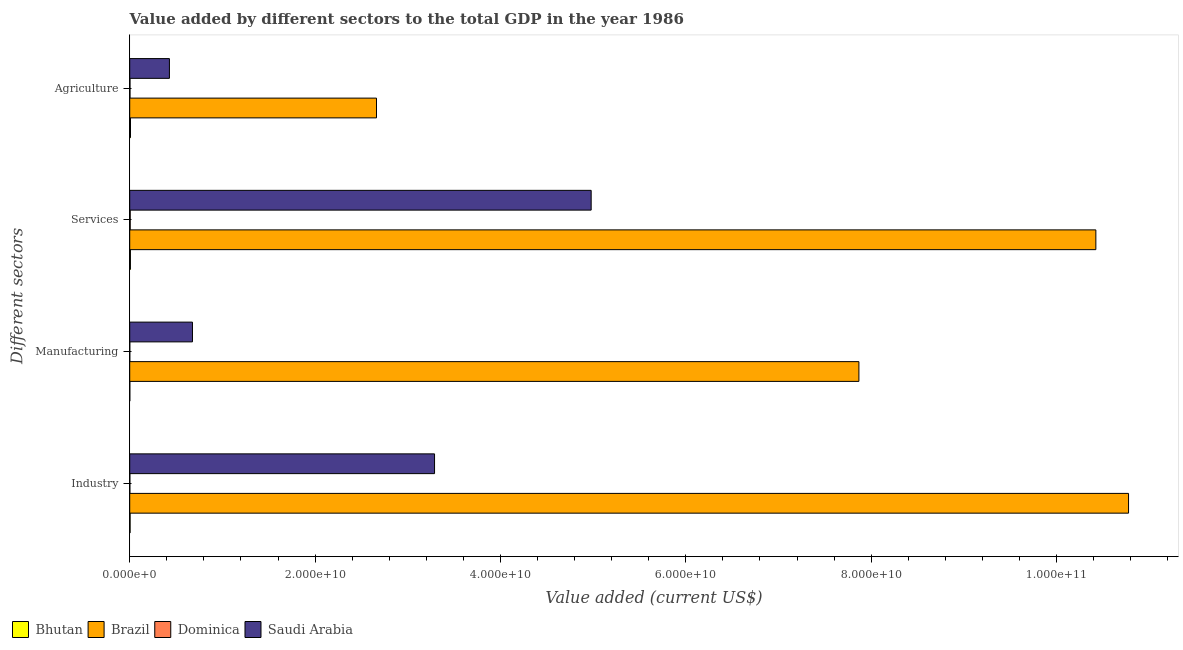How many groups of bars are there?
Give a very brief answer. 4. Are the number of bars per tick equal to the number of legend labels?
Make the answer very short. Yes. How many bars are there on the 3rd tick from the bottom?
Ensure brevity in your answer.  4. What is the label of the 4th group of bars from the top?
Provide a succinct answer. Industry. What is the value added by manufacturing sector in Brazil?
Offer a very short reply. 7.87e+1. Across all countries, what is the maximum value added by services sector?
Make the answer very short. 1.04e+11. Across all countries, what is the minimum value added by industrial sector?
Offer a very short reply. 1.36e+07. In which country was the value added by agricultural sector maximum?
Offer a terse response. Brazil. In which country was the value added by services sector minimum?
Ensure brevity in your answer.  Dominica. What is the total value added by manufacturing sector in the graph?
Provide a short and direct response. 8.55e+1. What is the difference between the value added by manufacturing sector in Dominica and that in Saudi Arabia?
Your answer should be very brief. -6.76e+09. What is the difference between the value added by agricultural sector in Bhutan and the value added by manufacturing sector in Dominica?
Offer a terse response. 7.71e+07. What is the average value added by agricultural sector per country?
Offer a very short reply. 7.76e+09. What is the difference between the value added by services sector and value added by manufacturing sector in Dominica?
Your response must be concise. 4.55e+07. What is the ratio of the value added by manufacturing sector in Bhutan to that in Dominica?
Provide a succinct answer. 1.63. What is the difference between the highest and the second highest value added by industrial sector?
Give a very brief answer. 7.49e+1. What is the difference between the highest and the lowest value added by agricultural sector?
Keep it short and to the point. 2.66e+1. In how many countries, is the value added by agricultural sector greater than the average value added by agricultural sector taken over all countries?
Your answer should be compact. 1. Is it the case that in every country, the sum of the value added by manufacturing sector and value added by services sector is greater than the sum of value added by agricultural sector and value added by industrial sector?
Provide a short and direct response. No. What does the 4th bar from the top in Services represents?
Give a very brief answer. Bhutan. What does the 4th bar from the bottom in Services represents?
Your response must be concise. Saudi Arabia. How many bars are there?
Offer a terse response. 16. How many countries are there in the graph?
Provide a short and direct response. 4. What is the difference between two consecutive major ticks on the X-axis?
Make the answer very short. 2.00e+1. Are the values on the major ticks of X-axis written in scientific E-notation?
Keep it short and to the point. Yes. Does the graph contain any zero values?
Your answer should be compact. No. Does the graph contain grids?
Ensure brevity in your answer.  No. Where does the legend appear in the graph?
Your answer should be very brief. Bottom left. How are the legend labels stacked?
Offer a terse response. Horizontal. What is the title of the graph?
Keep it short and to the point. Value added by different sectors to the total GDP in the year 1986. Does "Georgia" appear as one of the legend labels in the graph?
Provide a short and direct response. No. What is the label or title of the X-axis?
Provide a succinct answer. Value added (current US$). What is the label or title of the Y-axis?
Your response must be concise. Different sectors. What is the Value added (current US$) of Bhutan in Industry?
Offer a terse response. 3.98e+07. What is the Value added (current US$) in Brazil in Industry?
Offer a very short reply. 1.08e+11. What is the Value added (current US$) in Dominica in Industry?
Give a very brief answer. 1.36e+07. What is the Value added (current US$) in Saudi Arabia in Industry?
Provide a succinct answer. 3.29e+1. What is the Value added (current US$) in Bhutan in Manufacturing?
Make the answer very short. 1.02e+07. What is the Value added (current US$) of Brazil in Manufacturing?
Make the answer very short. 7.87e+1. What is the Value added (current US$) in Dominica in Manufacturing?
Keep it short and to the point. 6.26e+06. What is the Value added (current US$) of Saudi Arabia in Manufacturing?
Offer a very short reply. 6.77e+09. What is the Value added (current US$) in Bhutan in Services?
Offer a terse response. 7.48e+07. What is the Value added (current US$) in Brazil in Services?
Your answer should be compact. 1.04e+11. What is the Value added (current US$) of Dominica in Services?
Your answer should be compact. 5.18e+07. What is the Value added (current US$) in Saudi Arabia in Services?
Your answer should be compact. 4.98e+1. What is the Value added (current US$) of Bhutan in Agriculture?
Give a very brief answer. 8.34e+07. What is the Value added (current US$) of Brazil in Agriculture?
Your answer should be very brief. 2.66e+1. What is the Value added (current US$) in Dominica in Agriculture?
Provide a succinct answer. 2.84e+07. What is the Value added (current US$) of Saudi Arabia in Agriculture?
Provide a short and direct response. 4.28e+09. Across all Different sectors, what is the maximum Value added (current US$) of Bhutan?
Keep it short and to the point. 8.34e+07. Across all Different sectors, what is the maximum Value added (current US$) in Brazil?
Ensure brevity in your answer.  1.08e+11. Across all Different sectors, what is the maximum Value added (current US$) in Dominica?
Keep it short and to the point. 5.18e+07. Across all Different sectors, what is the maximum Value added (current US$) of Saudi Arabia?
Your answer should be very brief. 4.98e+1. Across all Different sectors, what is the minimum Value added (current US$) in Bhutan?
Give a very brief answer. 1.02e+07. Across all Different sectors, what is the minimum Value added (current US$) in Brazil?
Your answer should be very brief. 2.66e+1. Across all Different sectors, what is the minimum Value added (current US$) of Dominica?
Offer a very short reply. 6.26e+06. Across all Different sectors, what is the minimum Value added (current US$) in Saudi Arabia?
Provide a succinct answer. 4.28e+09. What is the total Value added (current US$) in Bhutan in the graph?
Ensure brevity in your answer.  2.08e+08. What is the total Value added (current US$) in Brazil in the graph?
Provide a succinct answer. 3.17e+11. What is the total Value added (current US$) of Dominica in the graph?
Provide a short and direct response. 1.00e+08. What is the total Value added (current US$) in Saudi Arabia in the graph?
Your answer should be very brief. 9.37e+1. What is the difference between the Value added (current US$) of Bhutan in Industry and that in Manufacturing?
Offer a terse response. 2.96e+07. What is the difference between the Value added (current US$) of Brazil in Industry and that in Manufacturing?
Ensure brevity in your answer.  2.91e+1. What is the difference between the Value added (current US$) of Dominica in Industry and that in Manufacturing?
Offer a very short reply. 7.37e+06. What is the difference between the Value added (current US$) of Saudi Arabia in Industry and that in Manufacturing?
Keep it short and to the point. 2.61e+1. What is the difference between the Value added (current US$) of Bhutan in Industry and that in Services?
Ensure brevity in your answer.  -3.50e+07. What is the difference between the Value added (current US$) in Brazil in Industry and that in Services?
Provide a succinct answer. 3.53e+09. What is the difference between the Value added (current US$) in Dominica in Industry and that in Services?
Offer a very short reply. -3.82e+07. What is the difference between the Value added (current US$) of Saudi Arabia in Industry and that in Services?
Provide a succinct answer. -1.69e+1. What is the difference between the Value added (current US$) in Bhutan in Industry and that in Agriculture?
Ensure brevity in your answer.  -4.35e+07. What is the difference between the Value added (current US$) in Brazil in Industry and that in Agriculture?
Provide a short and direct response. 8.11e+1. What is the difference between the Value added (current US$) of Dominica in Industry and that in Agriculture?
Make the answer very short. -1.47e+07. What is the difference between the Value added (current US$) in Saudi Arabia in Industry and that in Agriculture?
Your answer should be compact. 2.86e+1. What is the difference between the Value added (current US$) in Bhutan in Manufacturing and that in Services?
Provide a succinct answer. -6.46e+07. What is the difference between the Value added (current US$) of Brazil in Manufacturing and that in Services?
Your answer should be very brief. -2.56e+1. What is the difference between the Value added (current US$) in Dominica in Manufacturing and that in Services?
Give a very brief answer. -4.55e+07. What is the difference between the Value added (current US$) of Saudi Arabia in Manufacturing and that in Services?
Offer a very short reply. -4.30e+1. What is the difference between the Value added (current US$) in Bhutan in Manufacturing and that in Agriculture?
Your answer should be compact. -7.31e+07. What is the difference between the Value added (current US$) of Brazil in Manufacturing and that in Agriculture?
Make the answer very short. 5.21e+1. What is the difference between the Value added (current US$) in Dominica in Manufacturing and that in Agriculture?
Your answer should be compact. -2.21e+07. What is the difference between the Value added (current US$) in Saudi Arabia in Manufacturing and that in Agriculture?
Offer a very short reply. 2.49e+09. What is the difference between the Value added (current US$) of Bhutan in Services and that in Agriculture?
Offer a very short reply. -8.57e+06. What is the difference between the Value added (current US$) in Brazil in Services and that in Agriculture?
Provide a short and direct response. 7.76e+1. What is the difference between the Value added (current US$) in Dominica in Services and that in Agriculture?
Provide a short and direct response. 2.34e+07. What is the difference between the Value added (current US$) in Saudi Arabia in Services and that in Agriculture?
Offer a very short reply. 4.55e+1. What is the difference between the Value added (current US$) in Bhutan in Industry and the Value added (current US$) in Brazil in Manufacturing?
Provide a succinct answer. -7.86e+1. What is the difference between the Value added (current US$) of Bhutan in Industry and the Value added (current US$) of Dominica in Manufacturing?
Give a very brief answer. 3.36e+07. What is the difference between the Value added (current US$) of Bhutan in Industry and the Value added (current US$) of Saudi Arabia in Manufacturing?
Your response must be concise. -6.73e+09. What is the difference between the Value added (current US$) in Brazil in Industry and the Value added (current US$) in Dominica in Manufacturing?
Offer a terse response. 1.08e+11. What is the difference between the Value added (current US$) of Brazil in Industry and the Value added (current US$) of Saudi Arabia in Manufacturing?
Your response must be concise. 1.01e+11. What is the difference between the Value added (current US$) of Dominica in Industry and the Value added (current US$) of Saudi Arabia in Manufacturing?
Keep it short and to the point. -6.76e+09. What is the difference between the Value added (current US$) of Bhutan in Industry and the Value added (current US$) of Brazil in Services?
Offer a terse response. -1.04e+11. What is the difference between the Value added (current US$) in Bhutan in Industry and the Value added (current US$) in Dominica in Services?
Provide a succinct answer. -1.20e+07. What is the difference between the Value added (current US$) of Bhutan in Industry and the Value added (current US$) of Saudi Arabia in Services?
Make the answer very short. -4.97e+1. What is the difference between the Value added (current US$) in Brazil in Industry and the Value added (current US$) in Dominica in Services?
Offer a terse response. 1.08e+11. What is the difference between the Value added (current US$) of Brazil in Industry and the Value added (current US$) of Saudi Arabia in Services?
Offer a terse response. 5.80e+1. What is the difference between the Value added (current US$) in Dominica in Industry and the Value added (current US$) in Saudi Arabia in Services?
Offer a very short reply. -4.98e+1. What is the difference between the Value added (current US$) of Bhutan in Industry and the Value added (current US$) of Brazil in Agriculture?
Provide a succinct answer. -2.66e+1. What is the difference between the Value added (current US$) in Bhutan in Industry and the Value added (current US$) in Dominica in Agriculture?
Your answer should be compact. 1.14e+07. What is the difference between the Value added (current US$) in Bhutan in Industry and the Value added (current US$) in Saudi Arabia in Agriculture?
Give a very brief answer. -4.24e+09. What is the difference between the Value added (current US$) of Brazil in Industry and the Value added (current US$) of Dominica in Agriculture?
Keep it short and to the point. 1.08e+11. What is the difference between the Value added (current US$) in Brazil in Industry and the Value added (current US$) in Saudi Arabia in Agriculture?
Offer a terse response. 1.03e+11. What is the difference between the Value added (current US$) in Dominica in Industry and the Value added (current US$) in Saudi Arabia in Agriculture?
Offer a very short reply. -4.27e+09. What is the difference between the Value added (current US$) in Bhutan in Manufacturing and the Value added (current US$) in Brazil in Services?
Your answer should be compact. -1.04e+11. What is the difference between the Value added (current US$) in Bhutan in Manufacturing and the Value added (current US$) in Dominica in Services?
Provide a short and direct response. -4.16e+07. What is the difference between the Value added (current US$) of Bhutan in Manufacturing and the Value added (current US$) of Saudi Arabia in Services?
Offer a very short reply. -4.98e+1. What is the difference between the Value added (current US$) of Brazil in Manufacturing and the Value added (current US$) of Dominica in Services?
Your response must be concise. 7.86e+1. What is the difference between the Value added (current US$) of Brazil in Manufacturing and the Value added (current US$) of Saudi Arabia in Services?
Ensure brevity in your answer.  2.89e+1. What is the difference between the Value added (current US$) in Dominica in Manufacturing and the Value added (current US$) in Saudi Arabia in Services?
Offer a very short reply. -4.98e+1. What is the difference between the Value added (current US$) of Bhutan in Manufacturing and the Value added (current US$) of Brazil in Agriculture?
Offer a very short reply. -2.66e+1. What is the difference between the Value added (current US$) in Bhutan in Manufacturing and the Value added (current US$) in Dominica in Agriculture?
Keep it short and to the point. -1.82e+07. What is the difference between the Value added (current US$) of Bhutan in Manufacturing and the Value added (current US$) of Saudi Arabia in Agriculture?
Your answer should be compact. -4.27e+09. What is the difference between the Value added (current US$) of Brazil in Manufacturing and the Value added (current US$) of Dominica in Agriculture?
Make the answer very short. 7.87e+1. What is the difference between the Value added (current US$) of Brazil in Manufacturing and the Value added (current US$) of Saudi Arabia in Agriculture?
Keep it short and to the point. 7.44e+1. What is the difference between the Value added (current US$) in Dominica in Manufacturing and the Value added (current US$) in Saudi Arabia in Agriculture?
Make the answer very short. -4.28e+09. What is the difference between the Value added (current US$) in Bhutan in Services and the Value added (current US$) in Brazil in Agriculture?
Your response must be concise. -2.66e+1. What is the difference between the Value added (current US$) of Bhutan in Services and the Value added (current US$) of Dominica in Agriculture?
Keep it short and to the point. 4.64e+07. What is the difference between the Value added (current US$) of Bhutan in Services and the Value added (current US$) of Saudi Arabia in Agriculture?
Ensure brevity in your answer.  -4.21e+09. What is the difference between the Value added (current US$) in Brazil in Services and the Value added (current US$) in Dominica in Agriculture?
Your answer should be very brief. 1.04e+11. What is the difference between the Value added (current US$) in Brazil in Services and the Value added (current US$) in Saudi Arabia in Agriculture?
Make the answer very short. 1.00e+11. What is the difference between the Value added (current US$) of Dominica in Services and the Value added (current US$) of Saudi Arabia in Agriculture?
Offer a terse response. -4.23e+09. What is the average Value added (current US$) of Bhutan per Different sectors?
Provide a succinct answer. 5.20e+07. What is the average Value added (current US$) in Brazil per Different sectors?
Ensure brevity in your answer.  7.93e+1. What is the average Value added (current US$) in Dominica per Different sectors?
Give a very brief answer. 2.50e+07. What is the average Value added (current US$) of Saudi Arabia per Different sectors?
Provide a short and direct response. 2.34e+1. What is the difference between the Value added (current US$) in Bhutan and Value added (current US$) in Brazil in Industry?
Keep it short and to the point. -1.08e+11. What is the difference between the Value added (current US$) of Bhutan and Value added (current US$) of Dominica in Industry?
Your answer should be very brief. 2.62e+07. What is the difference between the Value added (current US$) in Bhutan and Value added (current US$) in Saudi Arabia in Industry?
Make the answer very short. -3.28e+1. What is the difference between the Value added (current US$) in Brazil and Value added (current US$) in Dominica in Industry?
Make the answer very short. 1.08e+11. What is the difference between the Value added (current US$) in Brazil and Value added (current US$) in Saudi Arabia in Industry?
Provide a short and direct response. 7.49e+1. What is the difference between the Value added (current US$) of Dominica and Value added (current US$) of Saudi Arabia in Industry?
Keep it short and to the point. -3.29e+1. What is the difference between the Value added (current US$) of Bhutan and Value added (current US$) of Brazil in Manufacturing?
Make the answer very short. -7.87e+1. What is the difference between the Value added (current US$) in Bhutan and Value added (current US$) in Dominica in Manufacturing?
Offer a very short reply. 3.95e+06. What is the difference between the Value added (current US$) in Bhutan and Value added (current US$) in Saudi Arabia in Manufacturing?
Provide a short and direct response. -6.76e+09. What is the difference between the Value added (current US$) in Brazil and Value added (current US$) in Dominica in Manufacturing?
Keep it short and to the point. 7.87e+1. What is the difference between the Value added (current US$) in Brazil and Value added (current US$) in Saudi Arabia in Manufacturing?
Offer a very short reply. 7.19e+1. What is the difference between the Value added (current US$) in Dominica and Value added (current US$) in Saudi Arabia in Manufacturing?
Provide a short and direct response. -6.76e+09. What is the difference between the Value added (current US$) of Bhutan and Value added (current US$) of Brazil in Services?
Your answer should be very brief. -1.04e+11. What is the difference between the Value added (current US$) in Bhutan and Value added (current US$) in Dominica in Services?
Provide a succinct answer. 2.30e+07. What is the difference between the Value added (current US$) in Bhutan and Value added (current US$) in Saudi Arabia in Services?
Offer a very short reply. -4.97e+1. What is the difference between the Value added (current US$) of Brazil and Value added (current US$) of Dominica in Services?
Make the answer very short. 1.04e+11. What is the difference between the Value added (current US$) of Brazil and Value added (current US$) of Saudi Arabia in Services?
Your response must be concise. 5.45e+1. What is the difference between the Value added (current US$) in Dominica and Value added (current US$) in Saudi Arabia in Services?
Your response must be concise. -4.97e+1. What is the difference between the Value added (current US$) in Bhutan and Value added (current US$) in Brazil in Agriculture?
Provide a short and direct response. -2.65e+1. What is the difference between the Value added (current US$) in Bhutan and Value added (current US$) in Dominica in Agriculture?
Your answer should be very brief. 5.50e+07. What is the difference between the Value added (current US$) in Bhutan and Value added (current US$) in Saudi Arabia in Agriculture?
Your answer should be very brief. -4.20e+09. What is the difference between the Value added (current US$) of Brazil and Value added (current US$) of Dominica in Agriculture?
Keep it short and to the point. 2.66e+1. What is the difference between the Value added (current US$) in Brazil and Value added (current US$) in Saudi Arabia in Agriculture?
Ensure brevity in your answer.  2.23e+1. What is the difference between the Value added (current US$) of Dominica and Value added (current US$) of Saudi Arabia in Agriculture?
Give a very brief answer. -4.25e+09. What is the ratio of the Value added (current US$) in Bhutan in Industry to that in Manufacturing?
Your response must be concise. 3.9. What is the ratio of the Value added (current US$) of Brazil in Industry to that in Manufacturing?
Make the answer very short. 1.37. What is the ratio of the Value added (current US$) in Dominica in Industry to that in Manufacturing?
Give a very brief answer. 2.18. What is the ratio of the Value added (current US$) in Saudi Arabia in Industry to that in Manufacturing?
Your response must be concise. 4.86. What is the ratio of the Value added (current US$) in Bhutan in Industry to that in Services?
Your answer should be very brief. 0.53. What is the ratio of the Value added (current US$) of Brazil in Industry to that in Services?
Make the answer very short. 1.03. What is the ratio of the Value added (current US$) of Dominica in Industry to that in Services?
Your answer should be very brief. 0.26. What is the ratio of the Value added (current US$) of Saudi Arabia in Industry to that in Services?
Make the answer very short. 0.66. What is the ratio of the Value added (current US$) of Bhutan in Industry to that in Agriculture?
Provide a succinct answer. 0.48. What is the ratio of the Value added (current US$) of Brazil in Industry to that in Agriculture?
Keep it short and to the point. 4.05. What is the ratio of the Value added (current US$) in Dominica in Industry to that in Agriculture?
Provide a succinct answer. 0.48. What is the ratio of the Value added (current US$) in Saudi Arabia in Industry to that in Agriculture?
Offer a terse response. 7.68. What is the ratio of the Value added (current US$) of Bhutan in Manufacturing to that in Services?
Offer a terse response. 0.14. What is the ratio of the Value added (current US$) in Brazil in Manufacturing to that in Services?
Keep it short and to the point. 0.75. What is the ratio of the Value added (current US$) in Dominica in Manufacturing to that in Services?
Keep it short and to the point. 0.12. What is the ratio of the Value added (current US$) of Saudi Arabia in Manufacturing to that in Services?
Keep it short and to the point. 0.14. What is the ratio of the Value added (current US$) in Bhutan in Manufacturing to that in Agriculture?
Give a very brief answer. 0.12. What is the ratio of the Value added (current US$) of Brazil in Manufacturing to that in Agriculture?
Provide a short and direct response. 2.96. What is the ratio of the Value added (current US$) in Dominica in Manufacturing to that in Agriculture?
Provide a short and direct response. 0.22. What is the ratio of the Value added (current US$) of Saudi Arabia in Manufacturing to that in Agriculture?
Your answer should be compact. 1.58. What is the ratio of the Value added (current US$) in Bhutan in Services to that in Agriculture?
Your answer should be very brief. 0.9. What is the ratio of the Value added (current US$) of Brazil in Services to that in Agriculture?
Offer a terse response. 3.92. What is the ratio of the Value added (current US$) of Dominica in Services to that in Agriculture?
Keep it short and to the point. 1.83. What is the ratio of the Value added (current US$) in Saudi Arabia in Services to that in Agriculture?
Offer a terse response. 11.62. What is the difference between the highest and the second highest Value added (current US$) in Bhutan?
Provide a short and direct response. 8.57e+06. What is the difference between the highest and the second highest Value added (current US$) of Brazil?
Offer a very short reply. 3.53e+09. What is the difference between the highest and the second highest Value added (current US$) of Dominica?
Make the answer very short. 2.34e+07. What is the difference between the highest and the second highest Value added (current US$) of Saudi Arabia?
Provide a short and direct response. 1.69e+1. What is the difference between the highest and the lowest Value added (current US$) in Bhutan?
Give a very brief answer. 7.31e+07. What is the difference between the highest and the lowest Value added (current US$) in Brazil?
Provide a succinct answer. 8.11e+1. What is the difference between the highest and the lowest Value added (current US$) in Dominica?
Your response must be concise. 4.55e+07. What is the difference between the highest and the lowest Value added (current US$) in Saudi Arabia?
Give a very brief answer. 4.55e+1. 